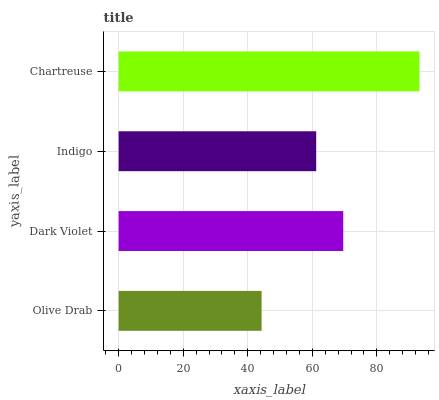Is Olive Drab the minimum?
Answer yes or no. Yes. Is Chartreuse the maximum?
Answer yes or no. Yes. Is Dark Violet the minimum?
Answer yes or no. No. Is Dark Violet the maximum?
Answer yes or no. No. Is Dark Violet greater than Olive Drab?
Answer yes or no. Yes. Is Olive Drab less than Dark Violet?
Answer yes or no. Yes. Is Olive Drab greater than Dark Violet?
Answer yes or no. No. Is Dark Violet less than Olive Drab?
Answer yes or no. No. Is Dark Violet the high median?
Answer yes or no. Yes. Is Indigo the low median?
Answer yes or no. Yes. Is Indigo the high median?
Answer yes or no. No. Is Chartreuse the low median?
Answer yes or no. No. 